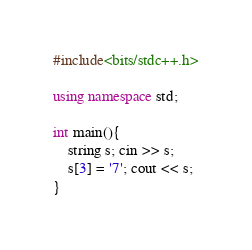Convert code to text. <code><loc_0><loc_0><loc_500><loc_500><_C++_>#include<bits/stdc++.h>

using namespace std;

int main(){
    string s; cin >> s;
    s[3] = '7'; cout << s;
}
</code> 